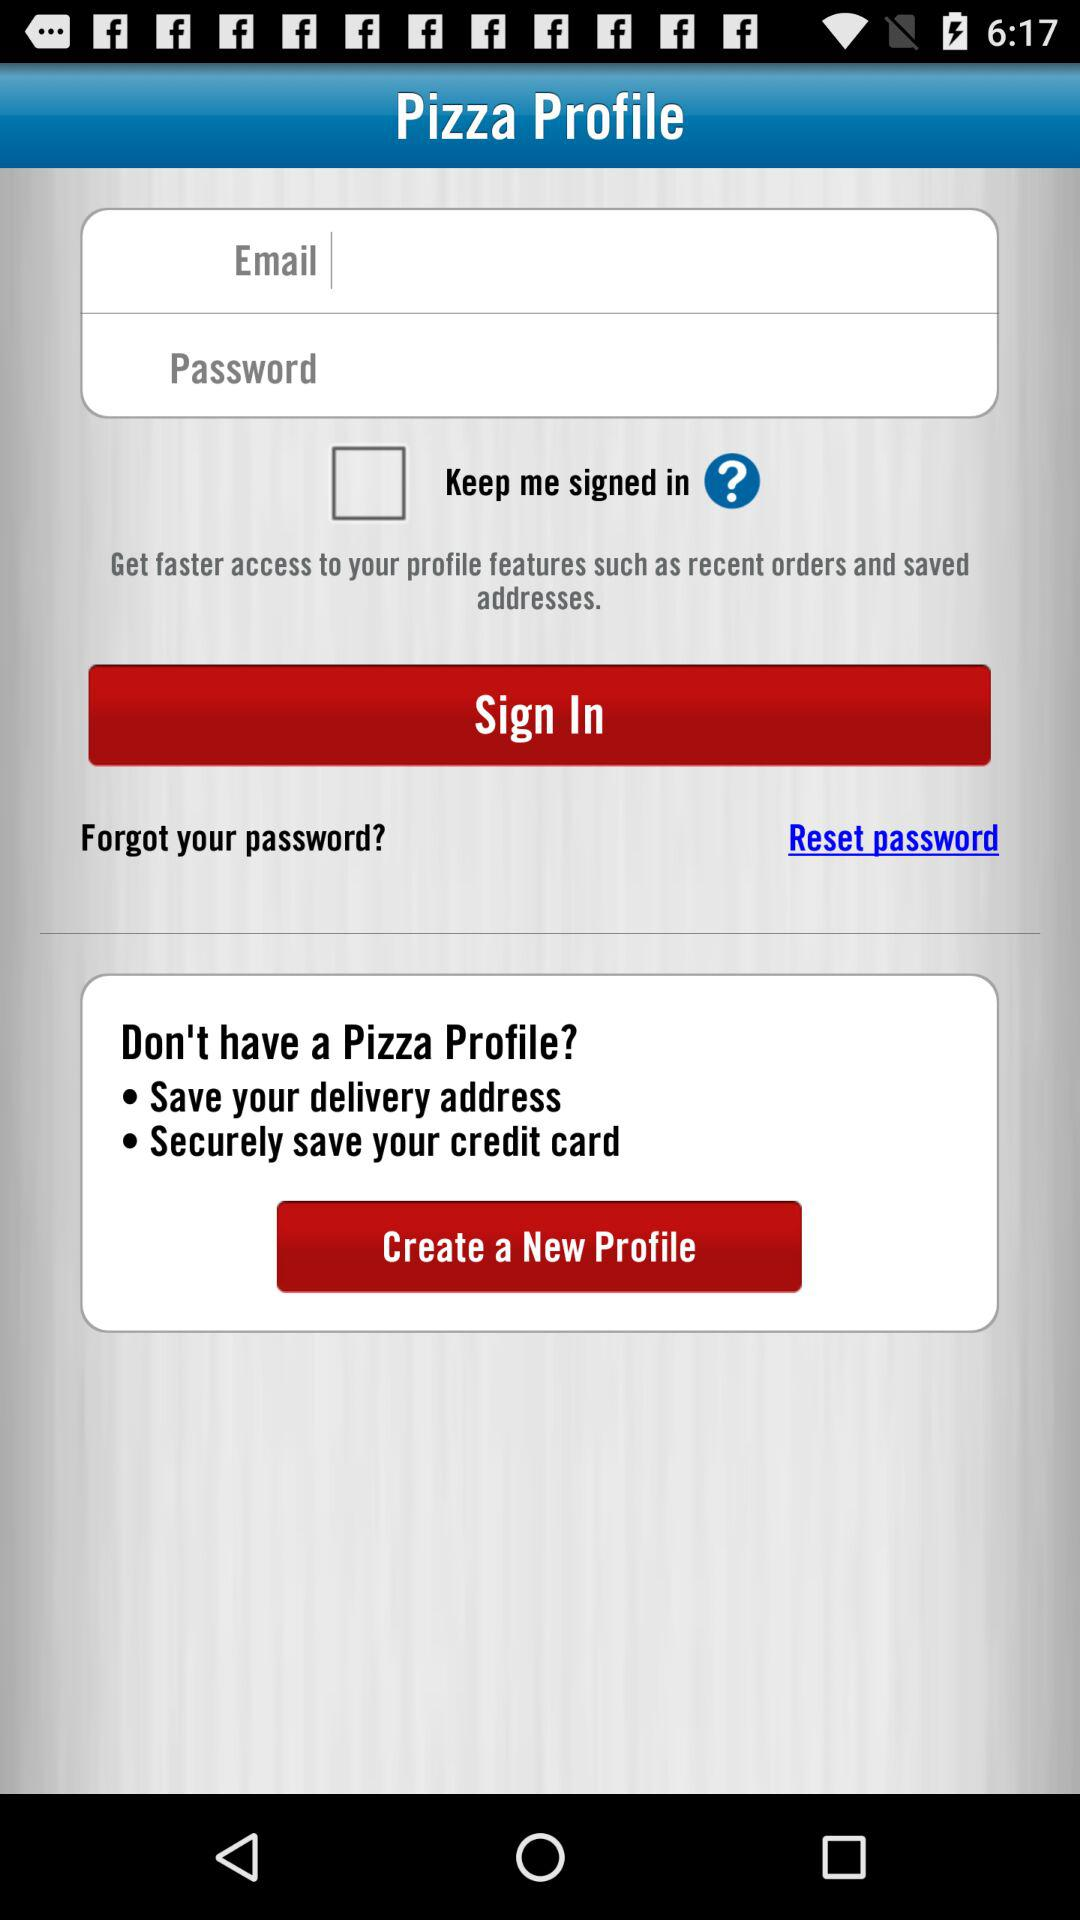What are the requirements to get signed in? The requirements to get signed in are email and password. 